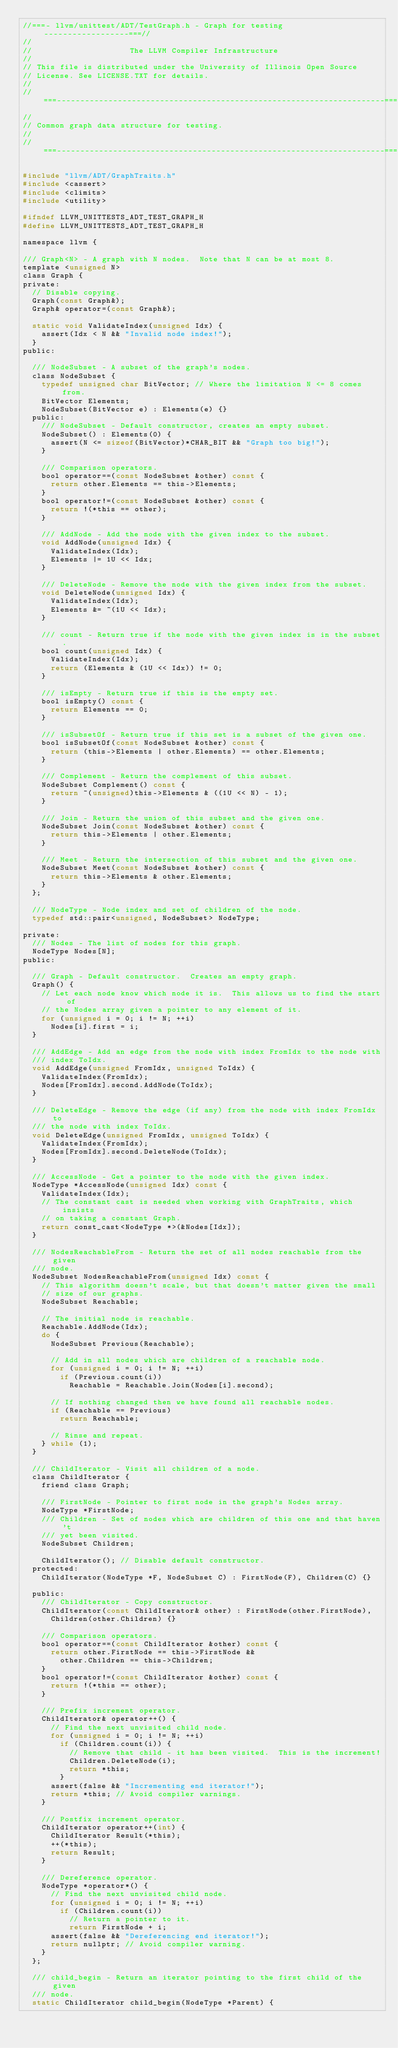<code> <loc_0><loc_0><loc_500><loc_500><_C_>//===- llvm/unittest/ADT/TestGraph.h - Graph for testing ------------------===//
//
//                     The LLVM Compiler Infrastructure
//
// This file is distributed under the University of Illinois Open Source
// License. See LICENSE.TXT for details.
//
//===----------------------------------------------------------------------===//
//
// Common graph data structure for testing.
//
//===----------------------------------------------------------------------===//

#include "llvm/ADT/GraphTraits.h"
#include <cassert>
#include <climits>
#include <utility>

#ifndef LLVM_UNITTESTS_ADT_TEST_GRAPH_H
#define LLVM_UNITTESTS_ADT_TEST_GRAPH_H

namespace llvm {

/// Graph<N> - A graph with N nodes.  Note that N can be at most 8.
template <unsigned N>
class Graph {
private:
  // Disable copying.
  Graph(const Graph&);
  Graph& operator=(const Graph&);

  static void ValidateIndex(unsigned Idx) {
    assert(Idx < N && "Invalid node index!");
  }
public:

  /// NodeSubset - A subset of the graph's nodes.
  class NodeSubset {
    typedef unsigned char BitVector; // Where the limitation N <= 8 comes from.
    BitVector Elements;
    NodeSubset(BitVector e) : Elements(e) {}
  public:
    /// NodeSubset - Default constructor, creates an empty subset.
    NodeSubset() : Elements(0) {
      assert(N <= sizeof(BitVector)*CHAR_BIT && "Graph too big!");
    }

    /// Comparison operators.
    bool operator==(const NodeSubset &other) const {
      return other.Elements == this->Elements;
    }
    bool operator!=(const NodeSubset &other) const {
      return !(*this == other);
    }

    /// AddNode - Add the node with the given index to the subset.
    void AddNode(unsigned Idx) {
      ValidateIndex(Idx);
      Elements |= 1U << Idx;
    }

    /// DeleteNode - Remove the node with the given index from the subset.
    void DeleteNode(unsigned Idx) {
      ValidateIndex(Idx);
      Elements &= ~(1U << Idx);
    }

    /// count - Return true if the node with the given index is in the subset.
    bool count(unsigned Idx) {
      ValidateIndex(Idx);
      return (Elements & (1U << Idx)) != 0;
    }

    /// isEmpty - Return true if this is the empty set.
    bool isEmpty() const {
      return Elements == 0;
    }

    /// isSubsetOf - Return true if this set is a subset of the given one.
    bool isSubsetOf(const NodeSubset &other) const {
      return (this->Elements | other.Elements) == other.Elements;
    }

    /// Complement - Return the complement of this subset.
    NodeSubset Complement() const {
      return ~(unsigned)this->Elements & ((1U << N) - 1);
    }

    /// Join - Return the union of this subset and the given one.
    NodeSubset Join(const NodeSubset &other) const {
      return this->Elements | other.Elements;
    }

    /// Meet - Return the intersection of this subset and the given one.
    NodeSubset Meet(const NodeSubset &other) const {
      return this->Elements & other.Elements;
    }
  };

  /// NodeType - Node index and set of children of the node.
  typedef std::pair<unsigned, NodeSubset> NodeType;

private:
  /// Nodes - The list of nodes for this graph.
  NodeType Nodes[N];
public:

  /// Graph - Default constructor.  Creates an empty graph.
  Graph() {
    // Let each node know which node it is.  This allows us to find the start of
    // the Nodes array given a pointer to any element of it.
    for (unsigned i = 0; i != N; ++i)
      Nodes[i].first = i;
  }

  /// AddEdge - Add an edge from the node with index FromIdx to the node with
  /// index ToIdx.
  void AddEdge(unsigned FromIdx, unsigned ToIdx) {
    ValidateIndex(FromIdx);
    Nodes[FromIdx].second.AddNode(ToIdx);
  }

  /// DeleteEdge - Remove the edge (if any) from the node with index FromIdx to
  /// the node with index ToIdx.
  void DeleteEdge(unsigned FromIdx, unsigned ToIdx) {
    ValidateIndex(FromIdx);
    Nodes[FromIdx].second.DeleteNode(ToIdx);
  }

  /// AccessNode - Get a pointer to the node with the given index.
  NodeType *AccessNode(unsigned Idx) const {
    ValidateIndex(Idx);
    // The constant cast is needed when working with GraphTraits, which insists
    // on taking a constant Graph.
    return const_cast<NodeType *>(&Nodes[Idx]);
  }

  /// NodesReachableFrom - Return the set of all nodes reachable from the given
  /// node.
  NodeSubset NodesReachableFrom(unsigned Idx) const {
    // This algorithm doesn't scale, but that doesn't matter given the small
    // size of our graphs.
    NodeSubset Reachable;

    // The initial node is reachable.
    Reachable.AddNode(Idx);
    do {
      NodeSubset Previous(Reachable);

      // Add in all nodes which are children of a reachable node.
      for (unsigned i = 0; i != N; ++i)
        if (Previous.count(i))
          Reachable = Reachable.Join(Nodes[i].second);

      // If nothing changed then we have found all reachable nodes.
      if (Reachable == Previous)
        return Reachable;

      // Rinse and repeat.
    } while (1);
  }

  /// ChildIterator - Visit all children of a node.
  class ChildIterator {
    friend class Graph;

    /// FirstNode - Pointer to first node in the graph's Nodes array.
    NodeType *FirstNode;
    /// Children - Set of nodes which are children of this one and that haven't
    /// yet been visited.
    NodeSubset Children;

    ChildIterator(); // Disable default constructor.
  protected:
    ChildIterator(NodeType *F, NodeSubset C) : FirstNode(F), Children(C) {}

  public:
    /// ChildIterator - Copy constructor.
    ChildIterator(const ChildIterator& other) : FirstNode(other.FirstNode),
      Children(other.Children) {}

    /// Comparison operators.
    bool operator==(const ChildIterator &other) const {
      return other.FirstNode == this->FirstNode &&
        other.Children == this->Children;
    }
    bool operator!=(const ChildIterator &other) const {
      return !(*this == other);
    }

    /// Prefix increment operator.
    ChildIterator& operator++() {
      // Find the next unvisited child node.
      for (unsigned i = 0; i != N; ++i)
        if (Children.count(i)) {
          // Remove that child - it has been visited.  This is the increment!
          Children.DeleteNode(i);
          return *this;
        }
      assert(false && "Incrementing end iterator!");
      return *this; // Avoid compiler warnings.
    }

    /// Postfix increment operator.
    ChildIterator operator++(int) {
      ChildIterator Result(*this);
      ++(*this);
      return Result;
    }

    /// Dereference operator.
    NodeType *operator*() {
      // Find the next unvisited child node.
      for (unsigned i = 0; i != N; ++i)
        if (Children.count(i))
          // Return a pointer to it.
          return FirstNode + i;
      assert(false && "Dereferencing end iterator!");
      return nullptr; // Avoid compiler warning.
    }
  };

  /// child_begin - Return an iterator pointing to the first child of the given
  /// node.
  static ChildIterator child_begin(NodeType *Parent) {</code> 